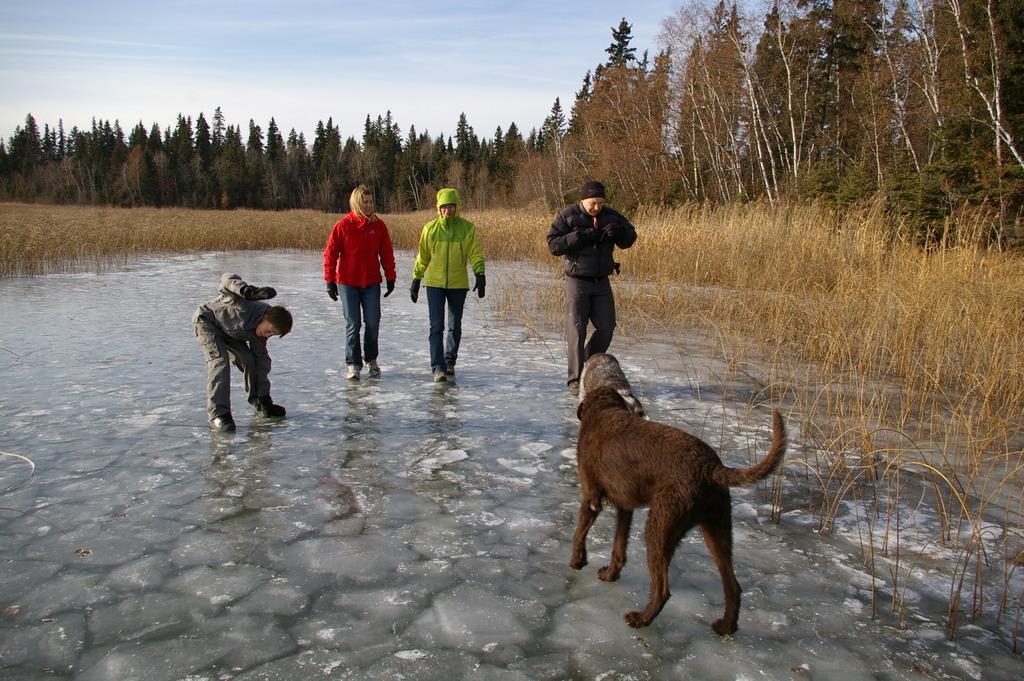In one or two sentences, can you explain what this image depicts? In this image we can see four members are walking, One is wearing grey color dress, the other one is wearing red jacket with jeans and third one is wearing green jacket with jeans and forth one is wearing black jacket and pant. In front of them animals are there. Behind them land with dry grass and trees are present. 